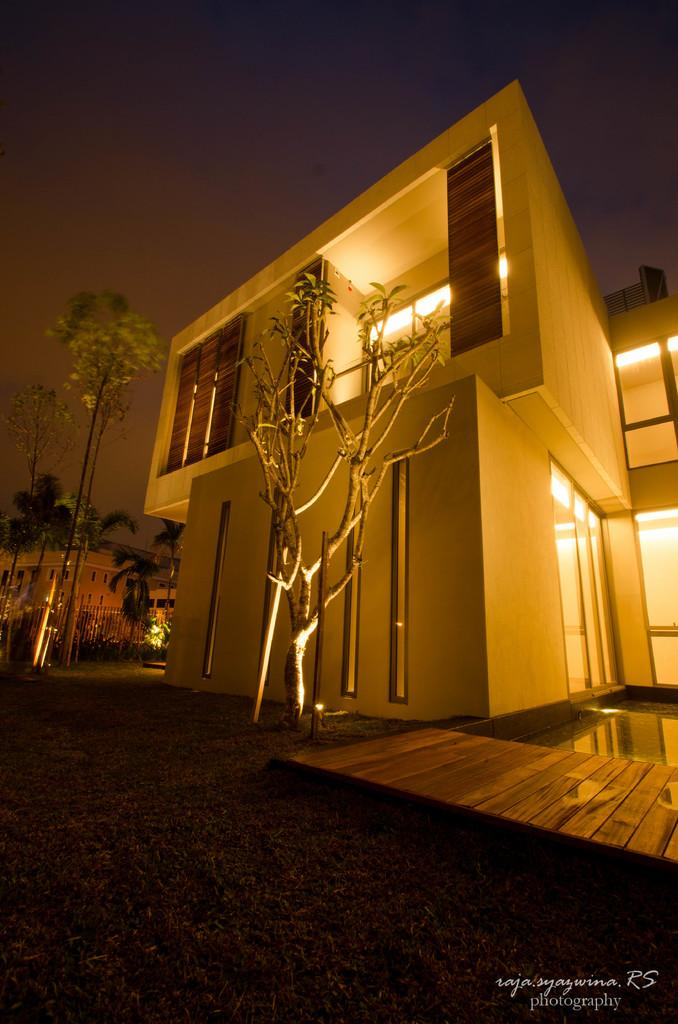What type of surface can be seen in the image? There is ground visible in the image. What natural elements are present in the image? There are trees in the image. What man-made structures can be seen in the image? There are buildings in the image. What type of illumination is present in the image? There are lights in the image. What type of water feature is visible in the image? There is water visible in the image. What type of vertical structures are present in the image? There are poles in the image. How would you describe the sky in the background of the image? The sky in the background appears dark. What type of yam is being used to decorate the buildings in the image? There is no yam present in the image, and therefore no such decoration can be observed. What type of silk is draped over the trees in the image? There is no silk present in the image, and therefore no such draping can be observed. 